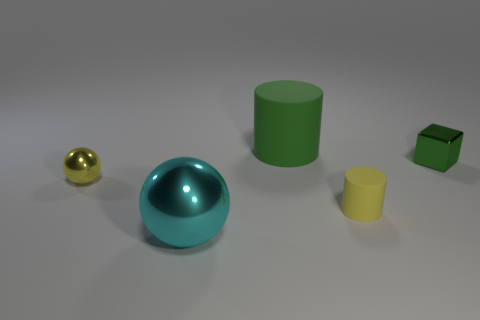Add 4 tiny green cubes. How many objects exist? 9 Subtract all balls. How many objects are left? 3 Add 4 large objects. How many large objects are left? 6 Add 4 tiny brown metal cylinders. How many tiny brown metal cylinders exist? 4 Subtract 0 red balls. How many objects are left? 5 Subtract all brown blocks. Subtract all yellow cylinders. How many blocks are left? 1 Subtract all tiny yellow things. Subtract all green rubber cylinders. How many objects are left? 2 